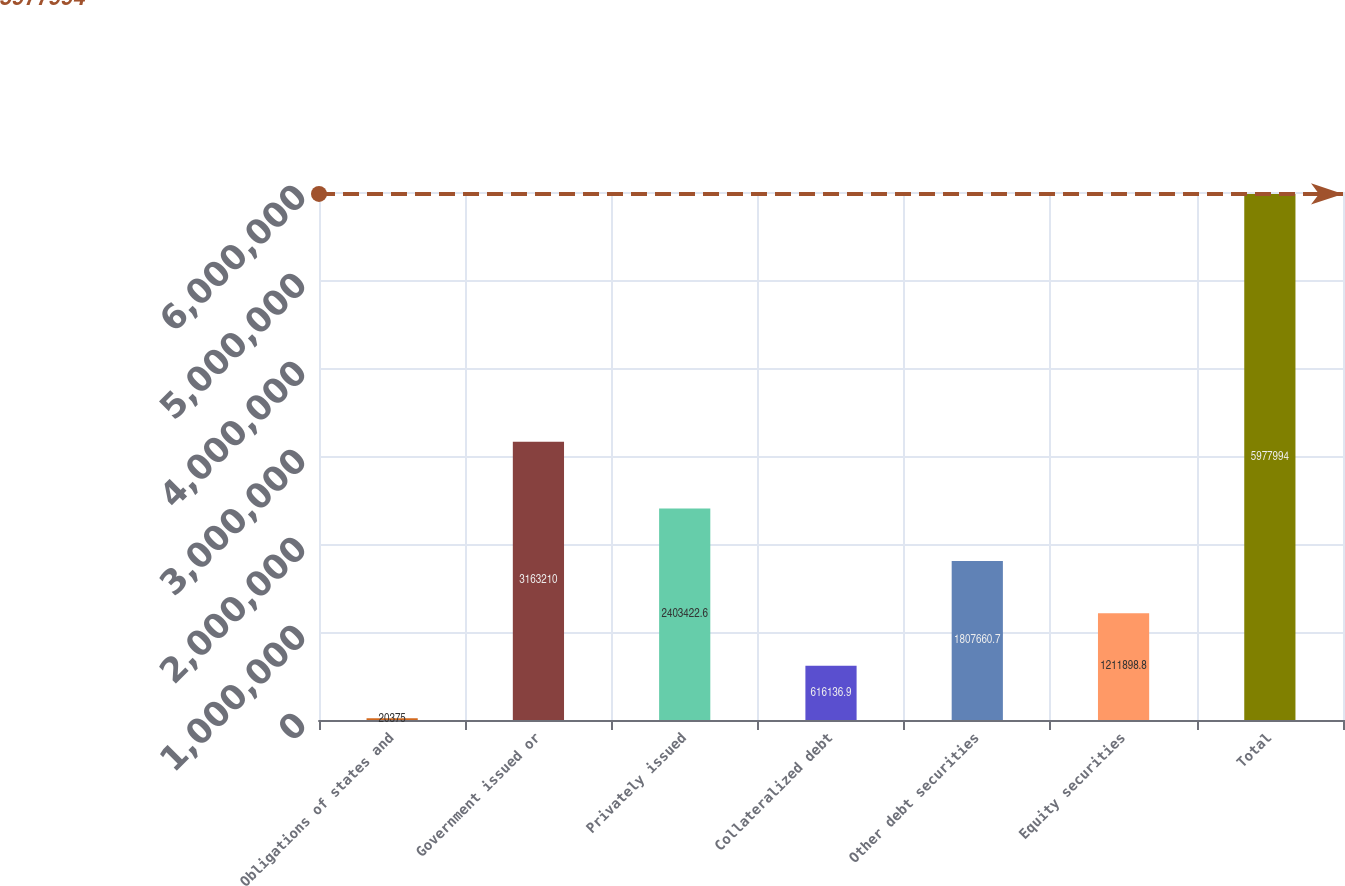Convert chart to OTSL. <chart><loc_0><loc_0><loc_500><loc_500><bar_chart><fcel>Obligations of states and<fcel>Government issued or<fcel>Privately issued<fcel>Collateralized debt<fcel>Other debt securities<fcel>Equity securities<fcel>Total<nl><fcel>20375<fcel>3.16321e+06<fcel>2.40342e+06<fcel>616137<fcel>1.80766e+06<fcel>1.2119e+06<fcel>5.97799e+06<nl></chart> 